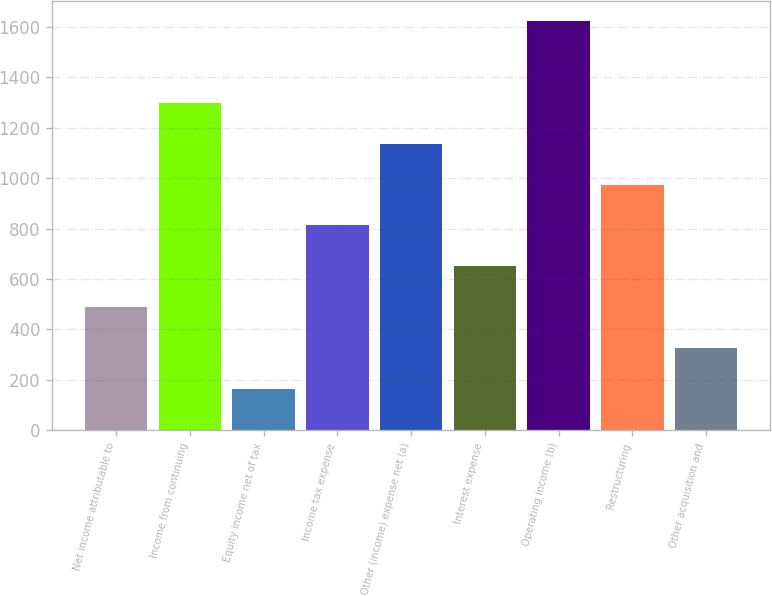<chart> <loc_0><loc_0><loc_500><loc_500><bar_chart><fcel>Net income attributable to<fcel>Income from continuing<fcel>Equity income net of tax<fcel>Income tax expense<fcel>Other (income) expense net (a)<fcel>Interest expense<fcel>Operating income (b)<fcel>Restructuring<fcel>Other acquisition and<nl><fcel>487.6<fcel>1298.6<fcel>163.2<fcel>812<fcel>1136.4<fcel>649.8<fcel>1623<fcel>974.2<fcel>325.4<nl></chart> 